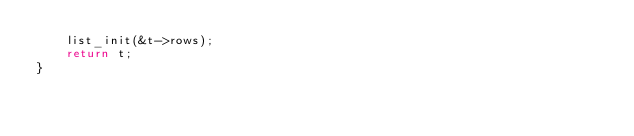Convert code to text. <code><loc_0><loc_0><loc_500><loc_500><_C_>    list_init(&t->rows);
    return t;
}
</code> 